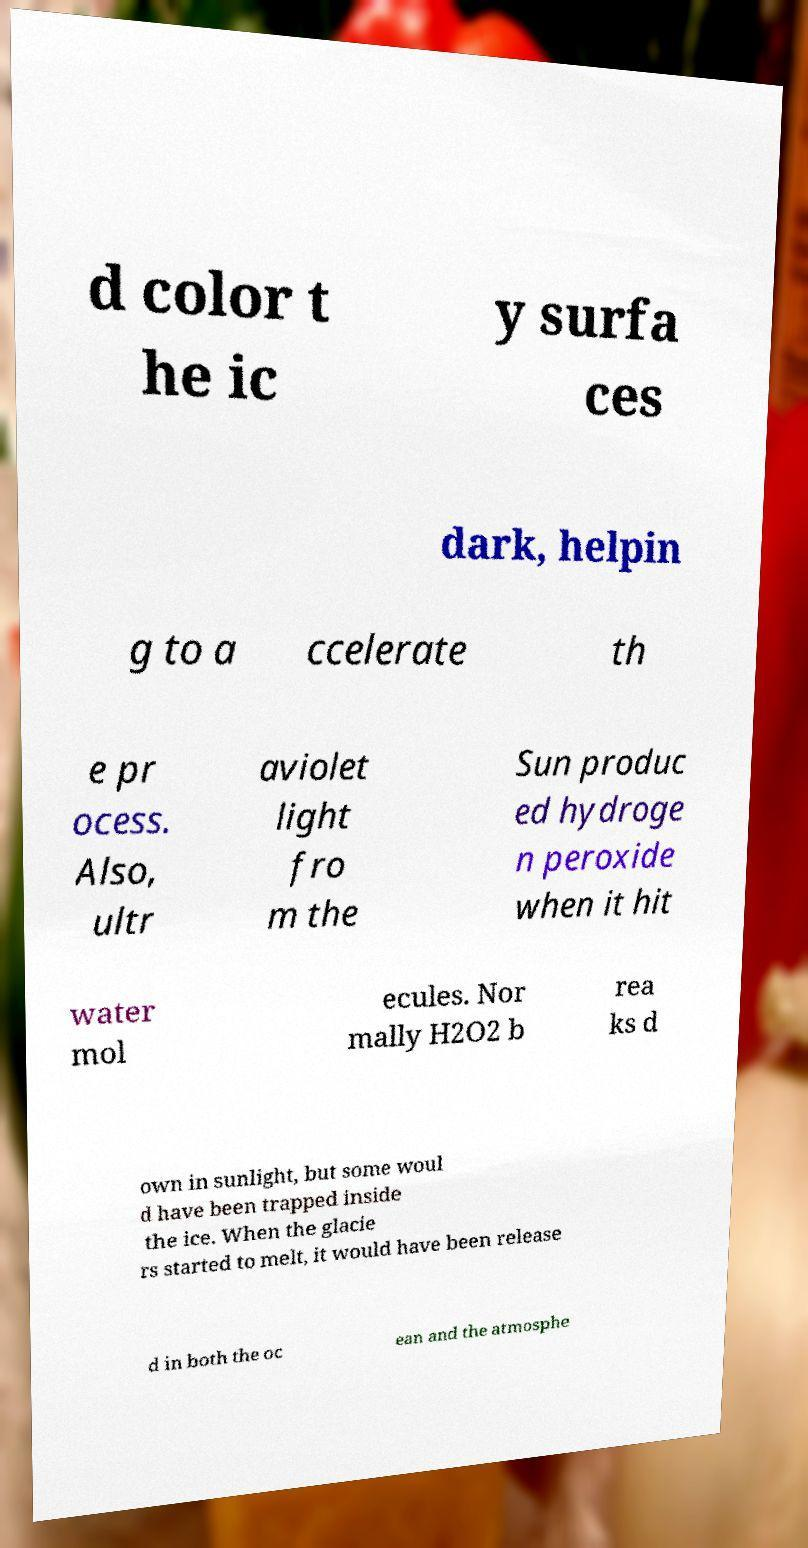I need the written content from this picture converted into text. Can you do that? d color t he ic y surfa ces dark, helpin g to a ccelerate th e pr ocess. Also, ultr aviolet light fro m the Sun produc ed hydroge n peroxide when it hit water mol ecules. Nor mally H2O2 b rea ks d own in sunlight, but some woul d have been trapped inside the ice. When the glacie rs started to melt, it would have been release d in both the oc ean and the atmosphe 